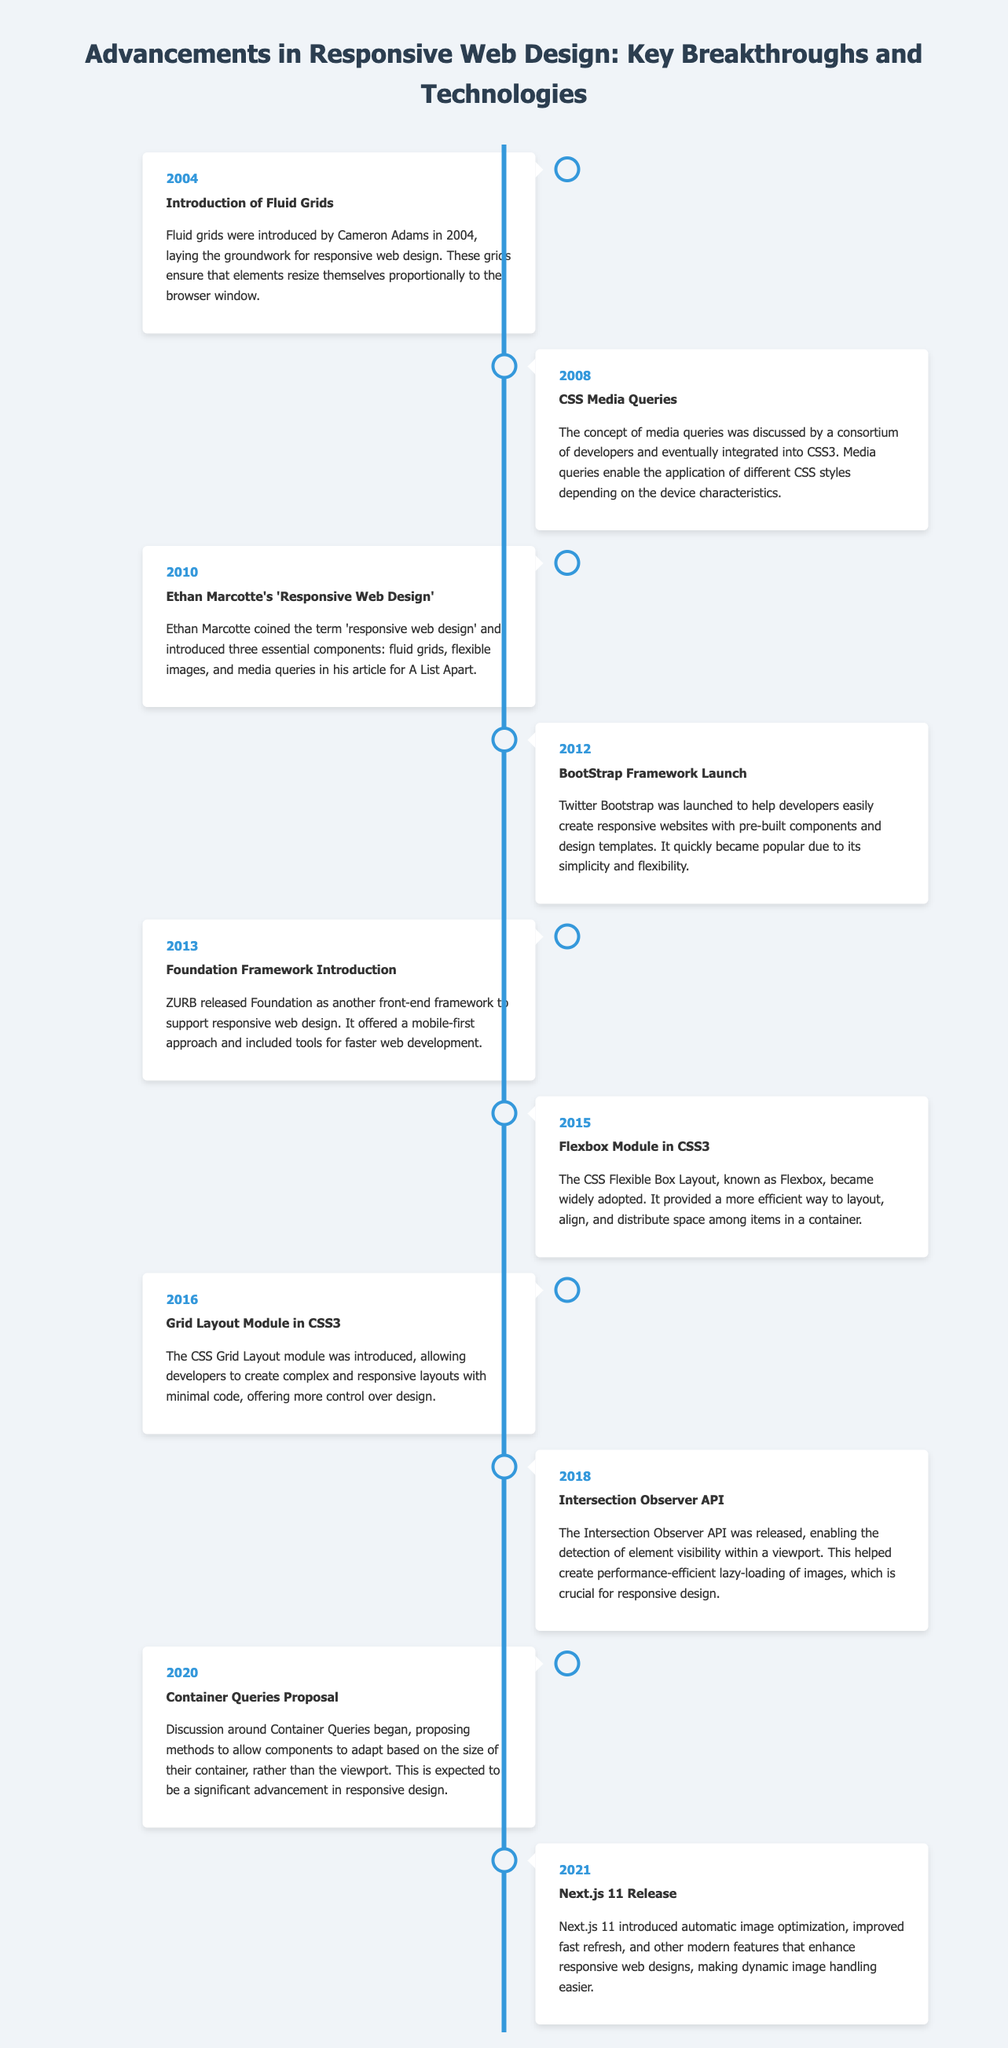What year were fluid grids introduced? The document states that fluid grids were introduced in 2004.
Answer: 2004 Who coined the term 'responsive web design'? The document mentions that Ethan Marcotte coined the term.
Answer: Ethan Marcotte What significant feature was launched with Twitter Bootstrap? The document highlights that Twitter Bootstrap was launched to help developers create responsive websites.
Answer: Responsive websites What framework was introduced in 2013? The document indicates that Foundation was introduced in 2013.
Answer: Foundation Which CSS module became widely adopted in 2015? According to the document, Flexbox Module in CSS3 became widely adopted in 2015.
Answer: Flexbox What technology allows for the detection of element visibility in 2018? The document states that the Intersection Observer API allows this detection.
Answer: Intersection Observer API What is a key proposal discussed around 2020? The document discusses the Container Queries Proposal as a key advancement.
Answer: Container Queries Proposal What enhancement does Next.js 11 provide? The document states that Next.js 11 introduced automatic image optimization.
Answer: Automatic image optimization 